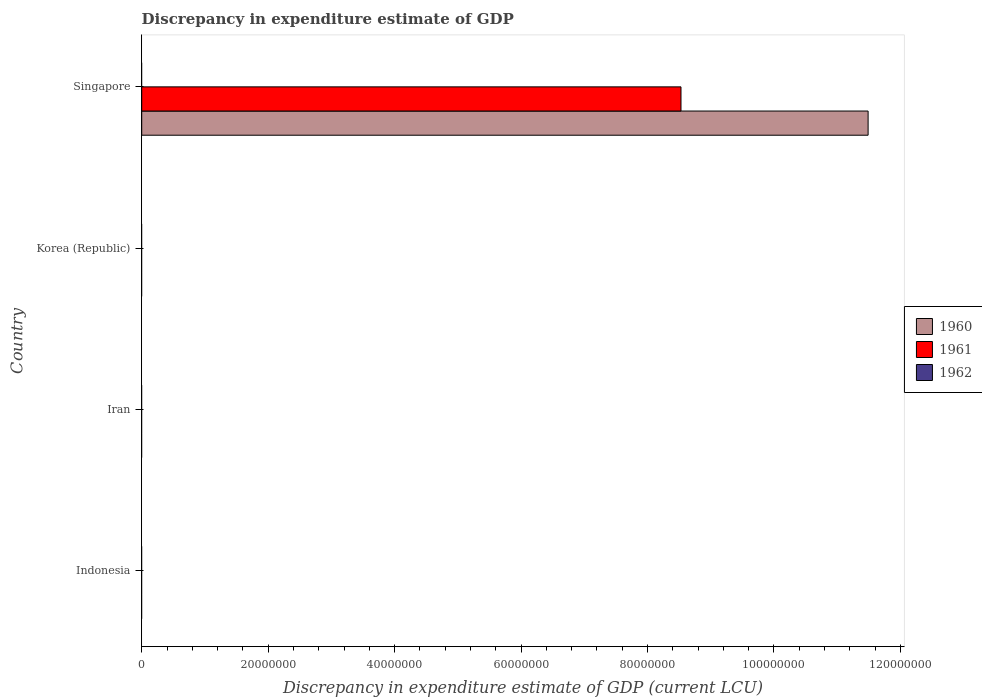How many different coloured bars are there?
Offer a very short reply. 2. Are the number of bars per tick equal to the number of legend labels?
Offer a very short reply. No. How many bars are there on the 1st tick from the top?
Keep it short and to the point. 2. How many bars are there on the 1st tick from the bottom?
Your answer should be very brief. 0. What is the label of the 3rd group of bars from the top?
Give a very brief answer. Iran. In how many cases, is the number of bars for a given country not equal to the number of legend labels?
Your answer should be compact. 4. Across all countries, what is the maximum discrepancy in expenditure estimate of GDP in 1961?
Provide a succinct answer. 8.53e+07. In which country was the discrepancy in expenditure estimate of GDP in 1961 maximum?
Offer a terse response. Singapore. What is the total discrepancy in expenditure estimate of GDP in 1960 in the graph?
Offer a terse response. 1.15e+08. What is the difference between the discrepancy in expenditure estimate of GDP in 1961 in Indonesia and the discrepancy in expenditure estimate of GDP in 1960 in Korea (Republic)?
Provide a succinct answer. 0. What is the average discrepancy in expenditure estimate of GDP in 1962 per country?
Provide a succinct answer. 0. What is the difference between the discrepancy in expenditure estimate of GDP in 1960 and discrepancy in expenditure estimate of GDP in 1961 in Singapore?
Offer a very short reply. 2.96e+07. What is the difference between the highest and the lowest discrepancy in expenditure estimate of GDP in 1960?
Your response must be concise. 1.15e+08. Is it the case that in every country, the sum of the discrepancy in expenditure estimate of GDP in 1961 and discrepancy in expenditure estimate of GDP in 1960 is greater than the discrepancy in expenditure estimate of GDP in 1962?
Provide a succinct answer. No. How many countries are there in the graph?
Give a very brief answer. 4. What is the difference between two consecutive major ticks on the X-axis?
Give a very brief answer. 2.00e+07. Does the graph contain any zero values?
Give a very brief answer. Yes. Does the graph contain grids?
Offer a terse response. No. How many legend labels are there?
Offer a very short reply. 3. What is the title of the graph?
Your answer should be very brief. Discrepancy in expenditure estimate of GDP. Does "1996" appear as one of the legend labels in the graph?
Provide a short and direct response. No. What is the label or title of the X-axis?
Your response must be concise. Discrepancy in expenditure estimate of GDP (current LCU). What is the label or title of the Y-axis?
Your response must be concise. Country. What is the Discrepancy in expenditure estimate of GDP (current LCU) of 1962 in Indonesia?
Your response must be concise. 0. What is the Discrepancy in expenditure estimate of GDP (current LCU) in 1960 in Iran?
Make the answer very short. 0. What is the Discrepancy in expenditure estimate of GDP (current LCU) of 1961 in Iran?
Make the answer very short. 0. What is the Discrepancy in expenditure estimate of GDP (current LCU) of 1962 in Iran?
Make the answer very short. 0. What is the Discrepancy in expenditure estimate of GDP (current LCU) of 1960 in Korea (Republic)?
Give a very brief answer. 0. What is the Discrepancy in expenditure estimate of GDP (current LCU) in 1960 in Singapore?
Your answer should be compact. 1.15e+08. What is the Discrepancy in expenditure estimate of GDP (current LCU) of 1961 in Singapore?
Ensure brevity in your answer.  8.53e+07. What is the Discrepancy in expenditure estimate of GDP (current LCU) in 1962 in Singapore?
Offer a terse response. 0. Across all countries, what is the maximum Discrepancy in expenditure estimate of GDP (current LCU) in 1960?
Offer a terse response. 1.15e+08. Across all countries, what is the maximum Discrepancy in expenditure estimate of GDP (current LCU) in 1961?
Provide a succinct answer. 8.53e+07. Across all countries, what is the minimum Discrepancy in expenditure estimate of GDP (current LCU) of 1960?
Your answer should be very brief. 0. What is the total Discrepancy in expenditure estimate of GDP (current LCU) of 1960 in the graph?
Offer a terse response. 1.15e+08. What is the total Discrepancy in expenditure estimate of GDP (current LCU) of 1961 in the graph?
Offer a very short reply. 8.53e+07. What is the total Discrepancy in expenditure estimate of GDP (current LCU) of 1962 in the graph?
Keep it short and to the point. 0. What is the average Discrepancy in expenditure estimate of GDP (current LCU) in 1960 per country?
Offer a very short reply. 2.87e+07. What is the average Discrepancy in expenditure estimate of GDP (current LCU) of 1961 per country?
Your answer should be very brief. 2.13e+07. What is the average Discrepancy in expenditure estimate of GDP (current LCU) of 1962 per country?
Ensure brevity in your answer.  0. What is the difference between the Discrepancy in expenditure estimate of GDP (current LCU) in 1960 and Discrepancy in expenditure estimate of GDP (current LCU) in 1961 in Singapore?
Make the answer very short. 2.96e+07. What is the difference between the highest and the lowest Discrepancy in expenditure estimate of GDP (current LCU) of 1960?
Offer a very short reply. 1.15e+08. What is the difference between the highest and the lowest Discrepancy in expenditure estimate of GDP (current LCU) of 1961?
Offer a very short reply. 8.53e+07. 